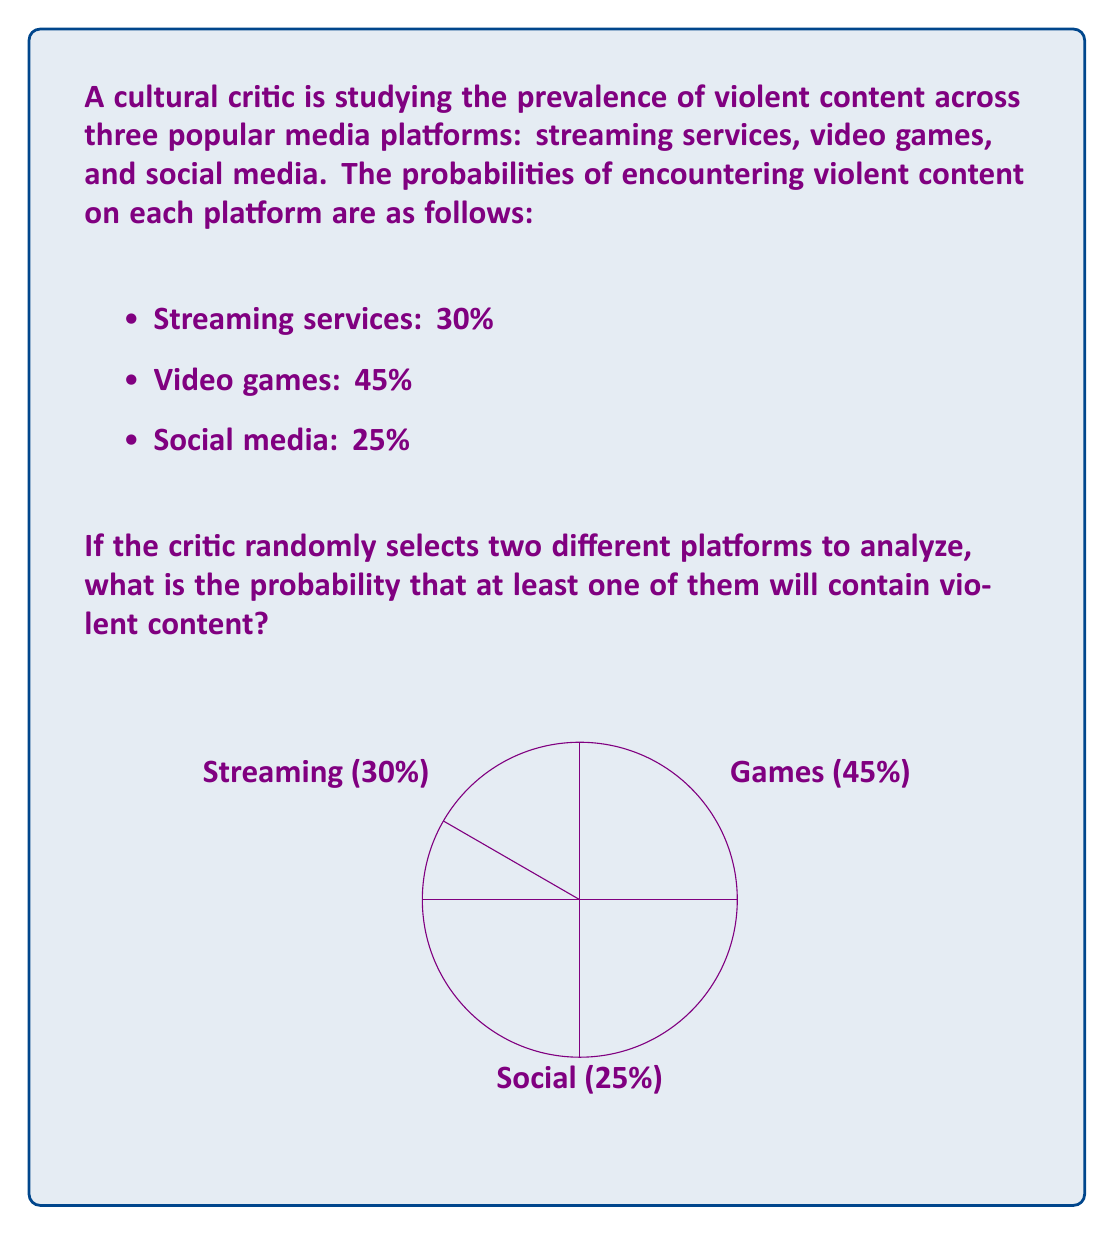Can you answer this question? Let's approach this step-by-step:

1) First, we need to calculate the probability of selecting any two platforms out of the three. This is a combination problem, and the number of ways to select 2 out of 3 is:

   $$\binom{3}{2} = \frac{3!}{2!(3-2)!} = 3$$

2) Now, let's calculate the probability of not encountering violent content on both selected platforms. We'll do this for each possible pair:

   a) Streaming and Games: $0.7 \times 0.55 = 0.385$
   b) Streaming and Social: $0.7 \times 0.75 = 0.525$
   c) Games and Social: $0.55 \times 0.75 = 0.4125$

3) The probability of encountering violent content on at least one platform is the opposite of not encountering it on either. So for each pair:

   a) $1 - 0.385 = 0.615$
   b) $1 - 0.525 = 0.475$
   c) $1 - 0.4125 = 0.5875$

4) Since each pair has an equal probability of being selected (1/3), we can calculate the overall probability by taking the average of these three probabilities:

   $$P(\text{at least one violent}) = \frac{0.615 + 0.475 + 0.5875}{3} = \frac{1.6775}{3} = 0.5592$$

5) Therefore, the probability of encountering violent content on at least one of two randomly selected platforms is approximately 0.5592 or 55.92%.
Answer: $0.5592$ or $55.92\%$ 